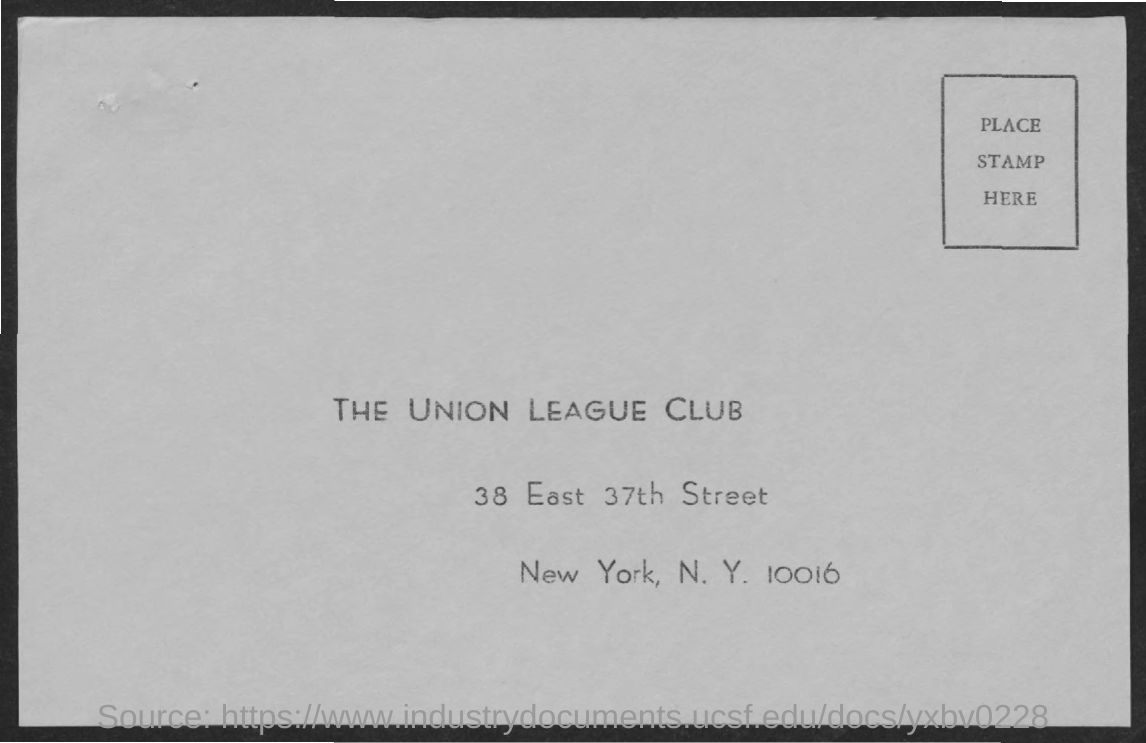What is the name of the club mentioned ?
Give a very brief answer. THE UNION LEAGUE CLUB. What is the street mentioned ?
Your answer should be very brief. 38 east 37th street. 